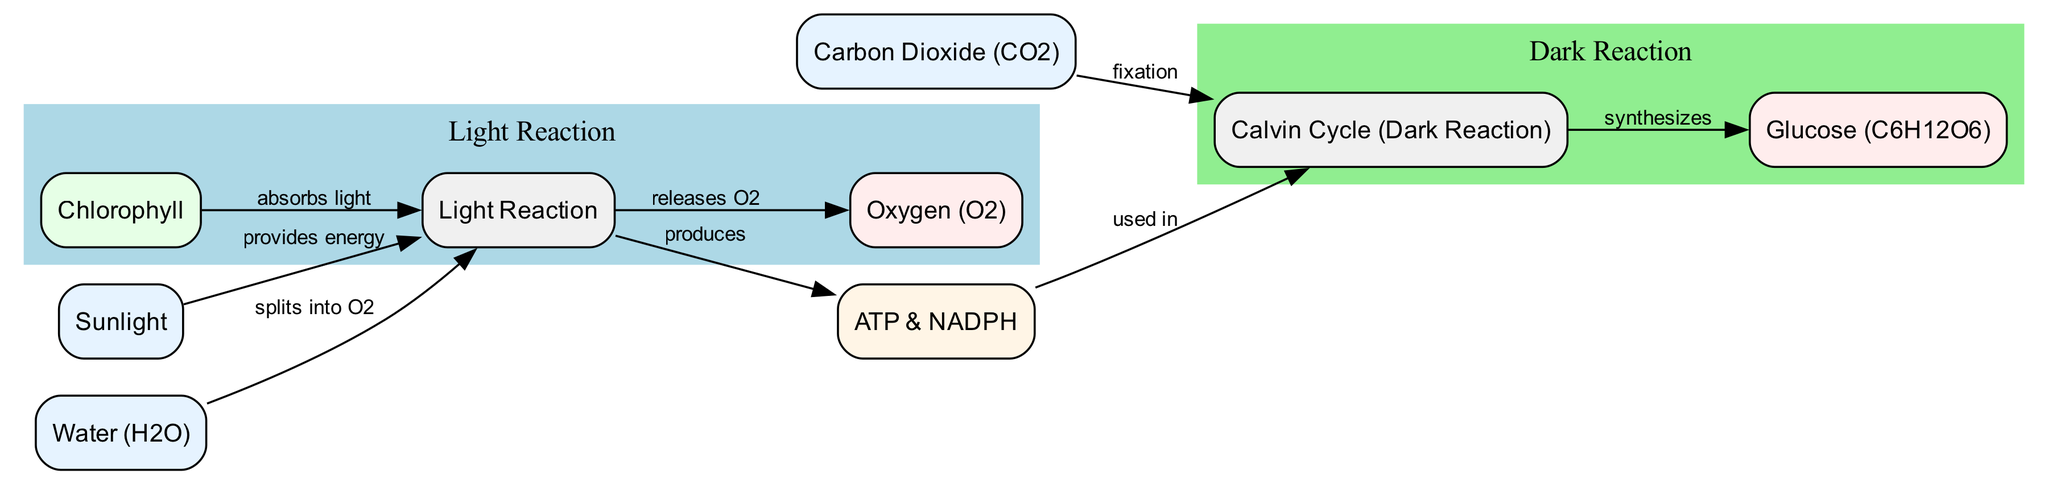What is the input that provides energy for the light reaction? The diagram shows that "Sunlight" is the input that provides energy to the "Light Reaction" node, as indicated by the connecting edge labeled "provides energy."
Answer: Sunlight What does water split into during the light reaction? The diagram indicates that water ("Water (H2O)") splits into "Oxygen (O2)" during the light reaction, as shown by the edge labeled "splits into O2" connected to the "Light Reaction" node.
Answer: Oxygen (O2) How many outputs are produced by the dark reaction? The diagram shows that there is one output produced by the dark reaction, which is "Glucose (C6H12O6)," connected by the edge labeled "synthesizes."
Answer: 1 What do ATP and NADPH provide for the dark reaction? According to the diagram, ATP and NADPH are used in the dark reaction as energy carriers, indicating their role in powering the processes within the "Calvin Cycle (Dark Reaction)." This is shown by the edge labeled "used in" pointing to the "Dark Reaction."
Answer: Energy What is the role of chlorophyll in the light reaction? The diagram indicates that chlorophyll absorbs light, as seen from the edge labeled "absorbs light" connecting the "Chlorophyll" node to the "Light Reaction" node. This points out the function of chlorophyll in the process of photosynthesis.
Answer: Absorbs light What is the result of the light reaction? The outcome of the light reaction, as indicated in the diagram, includes both "Oxygen (O2)" and "ATP & NADPH." "Oxygen" is shown as an output of the light reaction, while ATP and NADPH are produced and used in the dark reaction.
Answer: Oxygen (O2), ATP & NADPH What is the input for the dark reaction? The diagram shows that "Carbon Dioxide (CO2)" is an input for the dark reaction, as indicated by the edge labeled "fixation" connecting the "Carbon Dioxide" node to the "Calvin Cycle (Dark Reaction)" node.
Answer: Carbon Dioxide (CO2) What type of reaction is the Calvin Cycle classified as? The diagram indicates that the Calvin Cycle, also known as the "Dark Reaction," is classified as a process, and it specifically synthesizes glucose using the energy from ATP and NADPH.
Answer: Dark Reaction How many nodes represent inputs in the diagram? The diagram contains three input nodes, which are "Sunlight," "Water (H2O)," and "Carbon Dioxide (CO2)." This can be counted directly from the listed nodes under the "input" type.
Answer: 3 